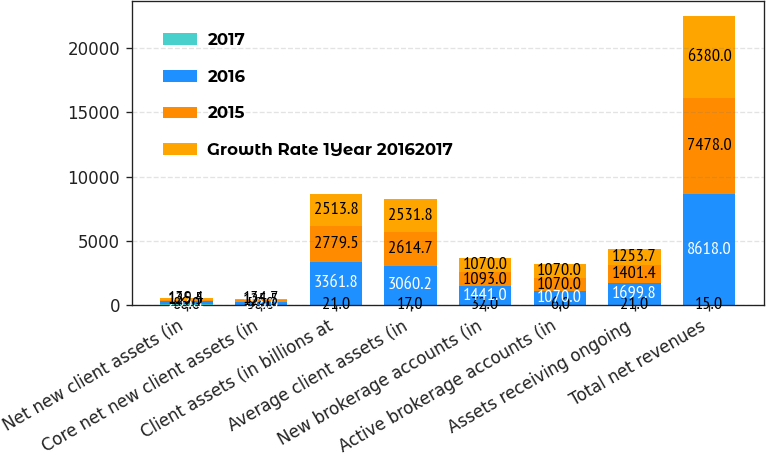<chart> <loc_0><loc_0><loc_500><loc_500><stacked_bar_chart><ecel><fcel>Net new client assets (in<fcel>Core net new client assets (in<fcel>Client assets (in billions at<fcel>Average client assets (in<fcel>New brokerage accounts (in<fcel>Active brokerage accounts (in<fcel>Assets receiving ongoing<fcel>Total net revenues<nl><fcel>2017<fcel>86<fcel>58<fcel>21<fcel>17<fcel>32<fcel>6<fcel>21<fcel>15<nl><fcel>2016<fcel>233.1<fcel>198.6<fcel>3361.8<fcel>3060.2<fcel>1441<fcel>1070<fcel>1699.8<fcel>8618<nl><fcel>2015<fcel>125.5<fcel>125.5<fcel>2779.5<fcel>2614.7<fcel>1093<fcel>1070<fcel>1401.4<fcel>7478<nl><fcel>Growth Rate 1Year 20162017<fcel>139.4<fcel>134.7<fcel>2513.8<fcel>2531.8<fcel>1070<fcel>1070<fcel>1253.7<fcel>6380<nl></chart> 